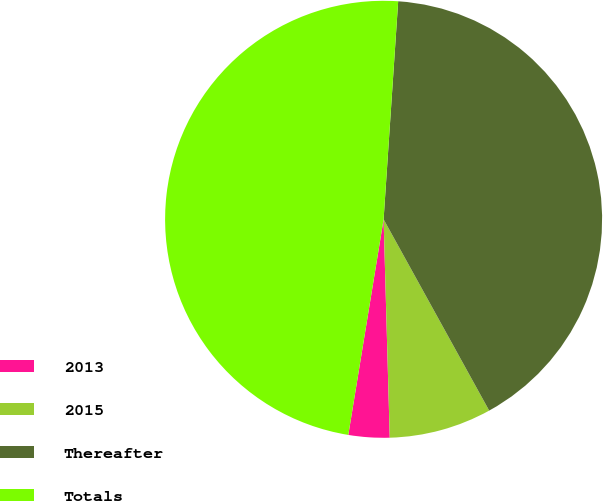Convert chart to OTSL. <chart><loc_0><loc_0><loc_500><loc_500><pie_chart><fcel>2013<fcel>2015<fcel>Thereafter<fcel>Totals<nl><fcel>3.03%<fcel>7.58%<fcel>40.91%<fcel>48.48%<nl></chart> 